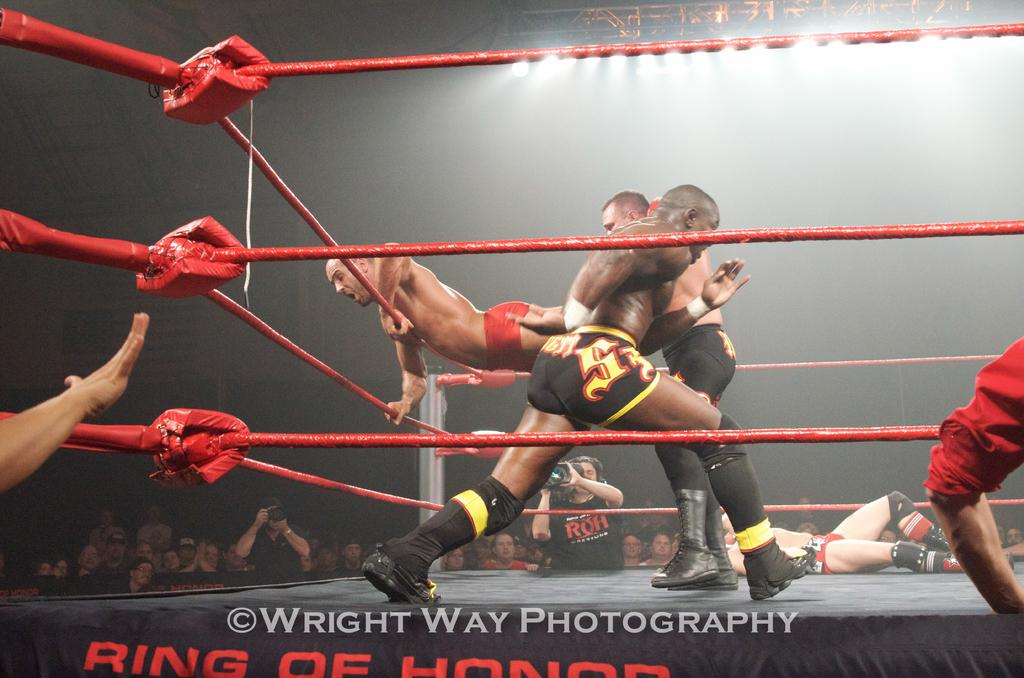<image>
Give a short and clear explanation of the subsequent image. Wrestling match that is presented by Wright Way Photography, Ring of Honor. 